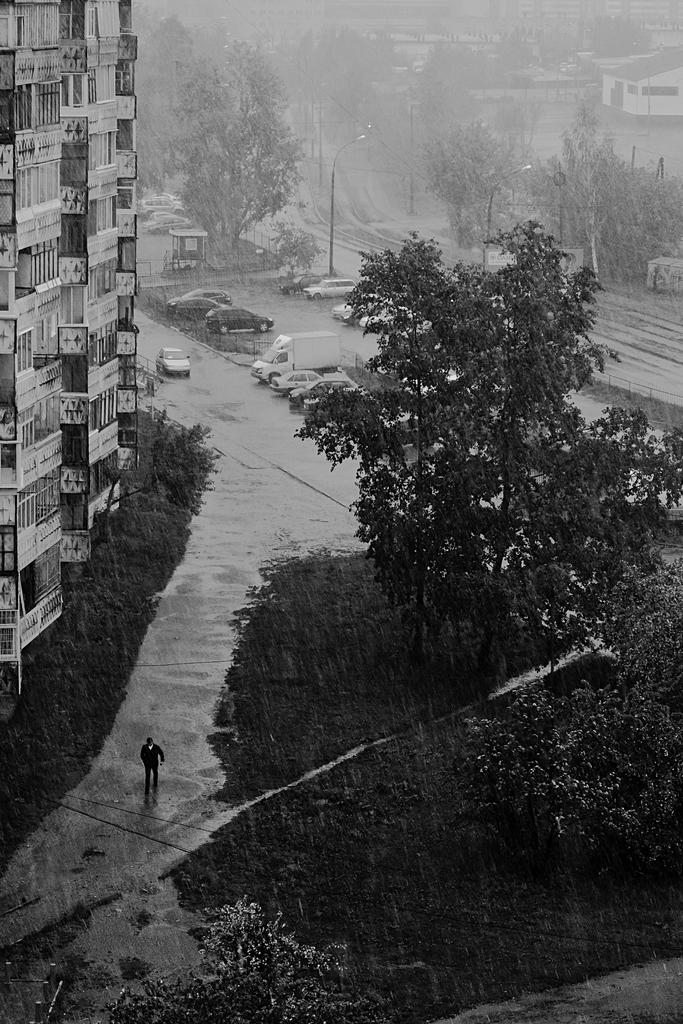What is the color scheme of the image? The image is black and white. What type of natural elements can be seen in the image? There are trees and grass in the image. What type of man-made structures are present in the image? There are buildings and poles in the image. What type of transportation is visible in the image? There are vehicles in the image. Are there any people present in the image? Yes, there is a person in the image. What type of balls can be seen being juggled by the doctor in the image? There is no doctor or balls present in the image. What type of seat is the person sitting on in the image? The provided facts do not mention a seat or any furniture in the image. 